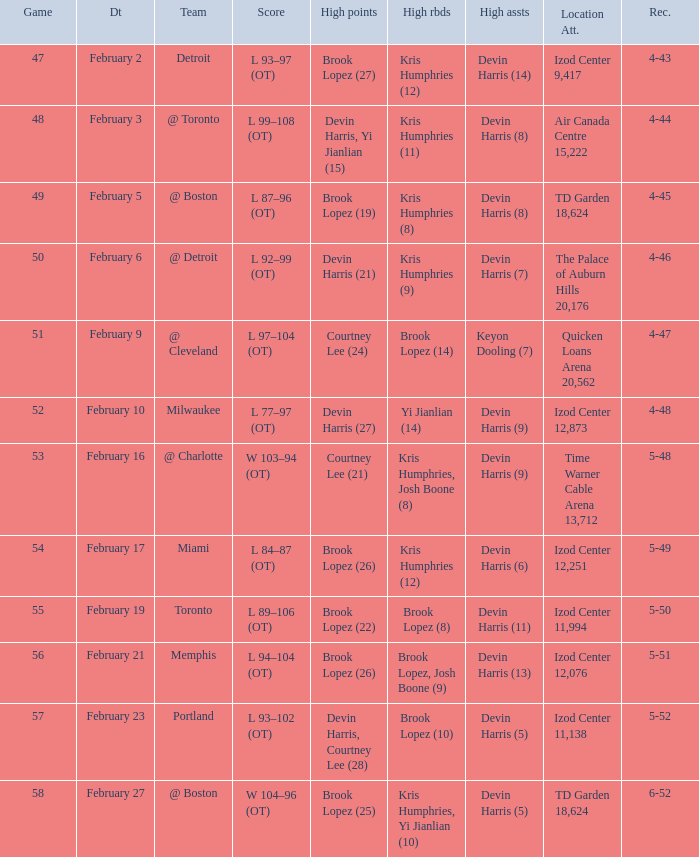Write the full table. {'header': ['Game', 'Dt', 'Team', 'Score', 'High points', 'High rbds', 'High assts', 'Location Att.', 'Rec.'], 'rows': [['47', 'February 2', 'Detroit', 'L 93–97 (OT)', 'Brook Lopez (27)', 'Kris Humphries (12)', 'Devin Harris (14)', 'Izod Center 9,417', '4-43'], ['48', 'February 3', '@ Toronto', 'L 99–108 (OT)', 'Devin Harris, Yi Jianlian (15)', 'Kris Humphries (11)', 'Devin Harris (8)', 'Air Canada Centre 15,222', '4-44'], ['49', 'February 5', '@ Boston', 'L 87–96 (OT)', 'Brook Lopez (19)', 'Kris Humphries (8)', 'Devin Harris (8)', 'TD Garden 18,624', '4-45'], ['50', 'February 6', '@ Detroit', 'L 92–99 (OT)', 'Devin Harris (21)', 'Kris Humphries (9)', 'Devin Harris (7)', 'The Palace of Auburn Hills 20,176', '4-46'], ['51', 'February 9', '@ Cleveland', 'L 97–104 (OT)', 'Courtney Lee (24)', 'Brook Lopez (14)', 'Keyon Dooling (7)', 'Quicken Loans Arena 20,562', '4-47'], ['52', 'February 10', 'Milwaukee', 'L 77–97 (OT)', 'Devin Harris (27)', 'Yi Jianlian (14)', 'Devin Harris (9)', 'Izod Center 12,873', '4-48'], ['53', 'February 16', '@ Charlotte', 'W 103–94 (OT)', 'Courtney Lee (21)', 'Kris Humphries, Josh Boone (8)', 'Devin Harris (9)', 'Time Warner Cable Arena 13,712', '5-48'], ['54', 'February 17', 'Miami', 'L 84–87 (OT)', 'Brook Lopez (26)', 'Kris Humphries (12)', 'Devin Harris (6)', 'Izod Center 12,251', '5-49'], ['55', 'February 19', 'Toronto', 'L 89–106 (OT)', 'Brook Lopez (22)', 'Brook Lopez (8)', 'Devin Harris (11)', 'Izod Center 11,994', '5-50'], ['56', 'February 21', 'Memphis', 'L 94–104 (OT)', 'Brook Lopez (26)', 'Brook Lopez, Josh Boone (9)', 'Devin Harris (13)', 'Izod Center 12,076', '5-51'], ['57', 'February 23', 'Portland', 'L 93–102 (OT)', 'Devin Harris, Courtney Lee (28)', 'Brook Lopez (10)', 'Devin Harris (5)', 'Izod Center 11,138', '5-52'], ['58', 'February 27', '@ Boston', 'W 104–96 (OT)', 'Brook Lopez (25)', 'Kris Humphries, Yi Jianlian (10)', 'Devin Harris (5)', 'TD Garden 18,624', '6-52']]} What team was the game on February 27 played against? @ Boston. 